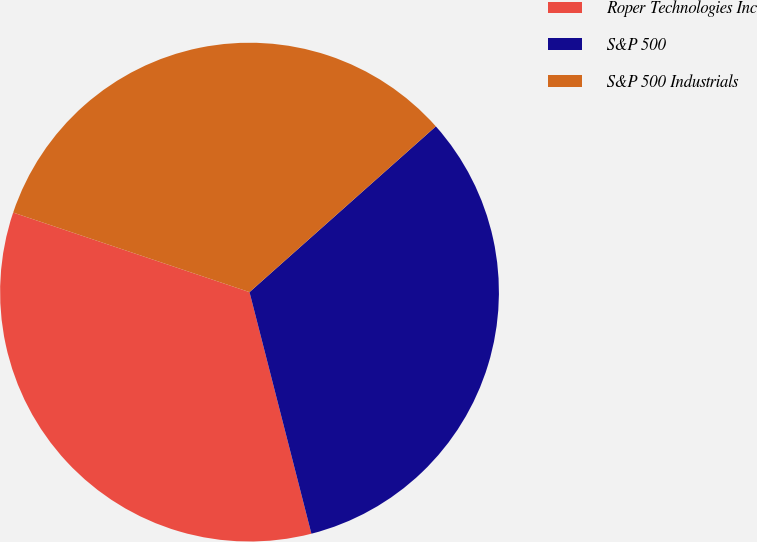Convert chart. <chart><loc_0><loc_0><loc_500><loc_500><pie_chart><fcel>Roper Technologies Inc<fcel>S&P 500<fcel>S&P 500 Industrials<nl><fcel>34.16%<fcel>32.58%<fcel>33.26%<nl></chart> 